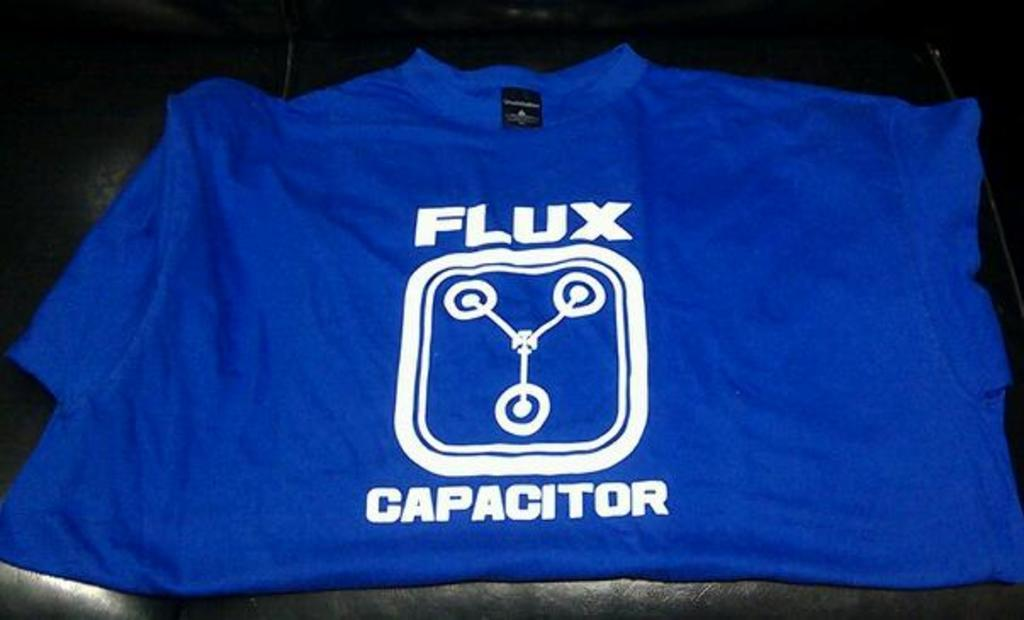<image>
Write a terse but informative summary of the picture. A blue shirt with FLUX CAPACITOR written on it is laying on a black leathery surface. 